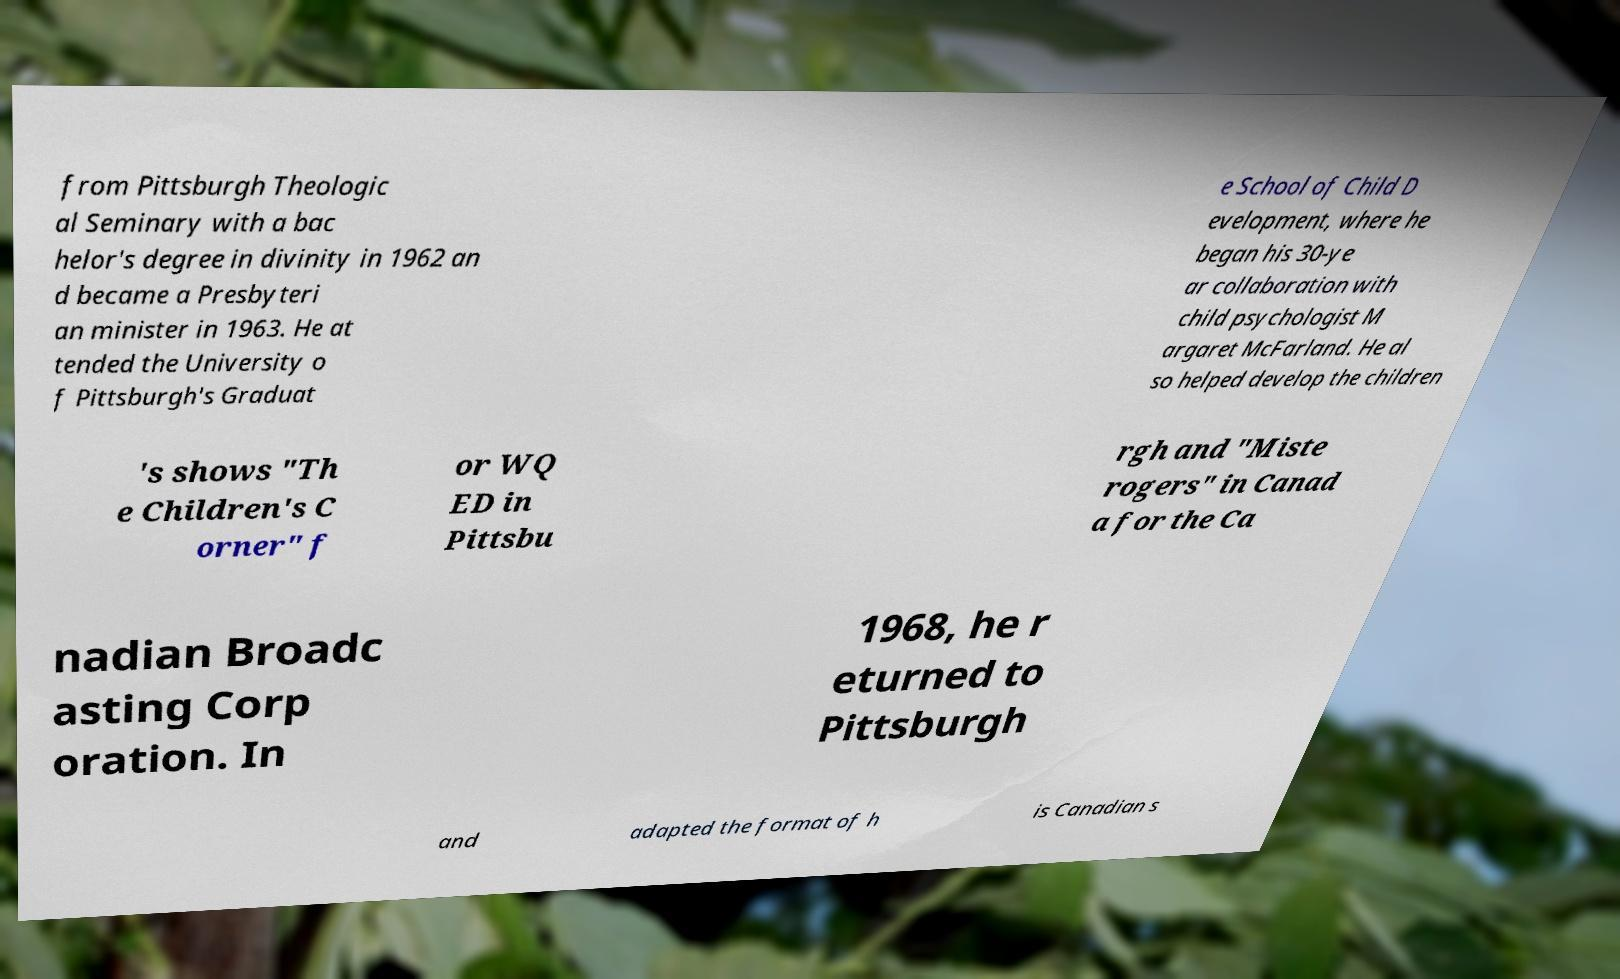Could you assist in decoding the text presented in this image and type it out clearly? from Pittsburgh Theologic al Seminary with a bac helor's degree in divinity in 1962 an d became a Presbyteri an minister in 1963. He at tended the University o f Pittsburgh's Graduat e School of Child D evelopment, where he began his 30-ye ar collaboration with child psychologist M argaret McFarland. He al so helped develop the children 's shows "Th e Children's C orner" f or WQ ED in Pittsbu rgh and "Miste rogers" in Canad a for the Ca nadian Broadc asting Corp oration. In 1968, he r eturned to Pittsburgh and adapted the format of h is Canadian s 